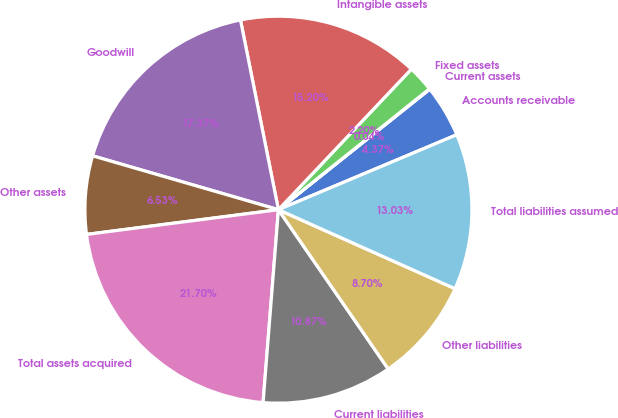Convert chart. <chart><loc_0><loc_0><loc_500><loc_500><pie_chart><fcel>Accounts receivable<fcel>Current assets<fcel>Fixed assets<fcel>Intangible assets<fcel>Goodwill<fcel>Other assets<fcel>Total assets acquired<fcel>Current liabilities<fcel>Other liabilities<fcel>Total liabilities assumed<nl><fcel>4.37%<fcel>0.04%<fcel>2.2%<fcel>15.2%<fcel>17.37%<fcel>6.53%<fcel>21.7%<fcel>10.87%<fcel>8.7%<fcel>13.03%<nl></chart> 